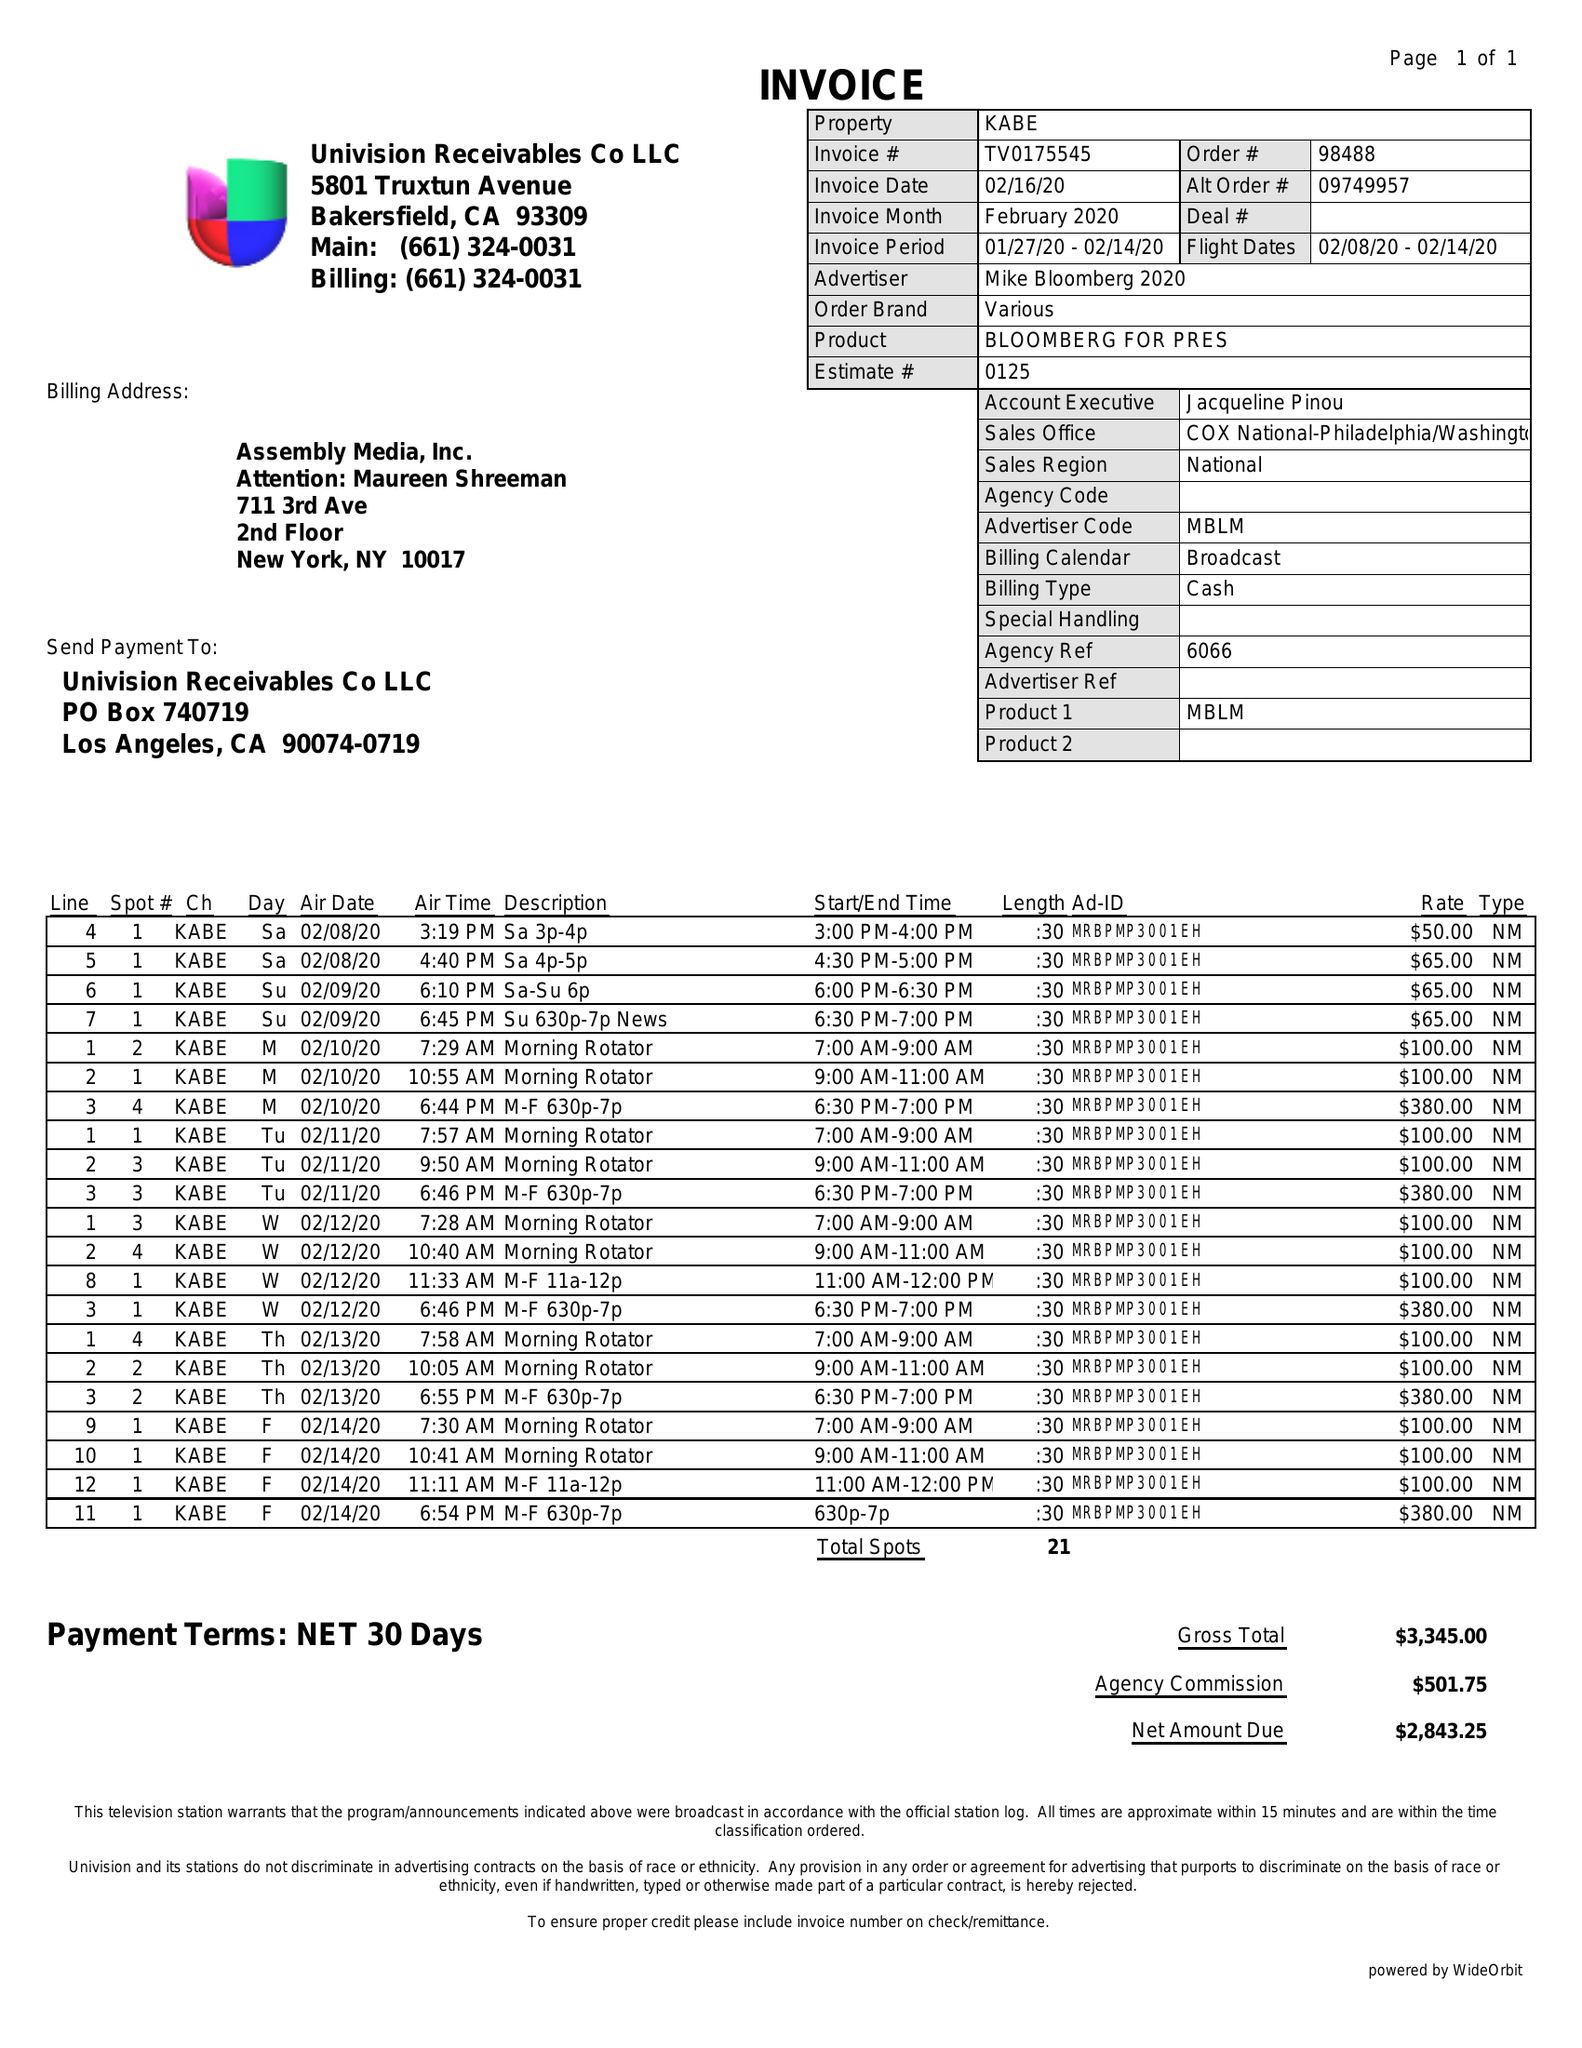What is the value for the flight_from?
Answer the question using a single word or phrase. 02/08/20 